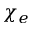Convert formula to latex. <formula><loc_0><loc_0><loc_500><loc_500>\chi _ { e }</formula> 